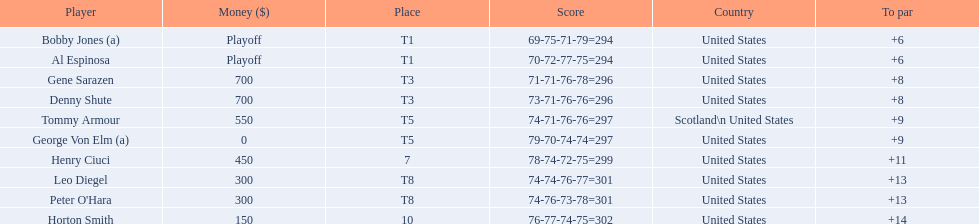Gene sarazen and denny shute are both from which country? United States. 